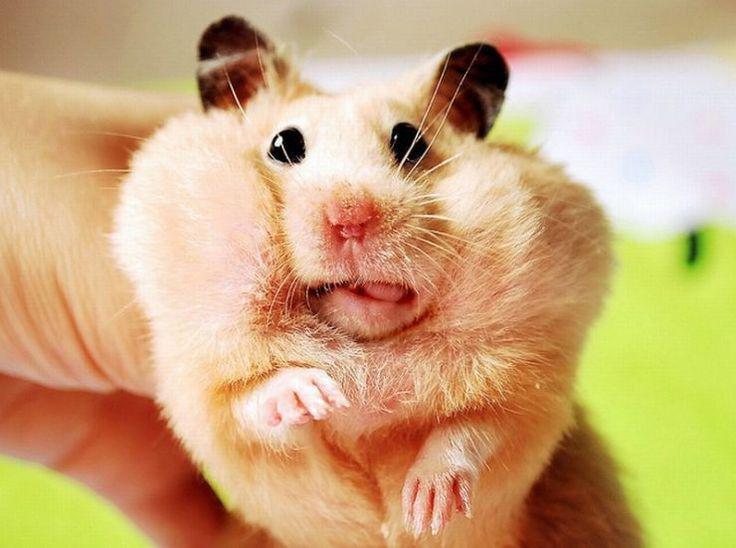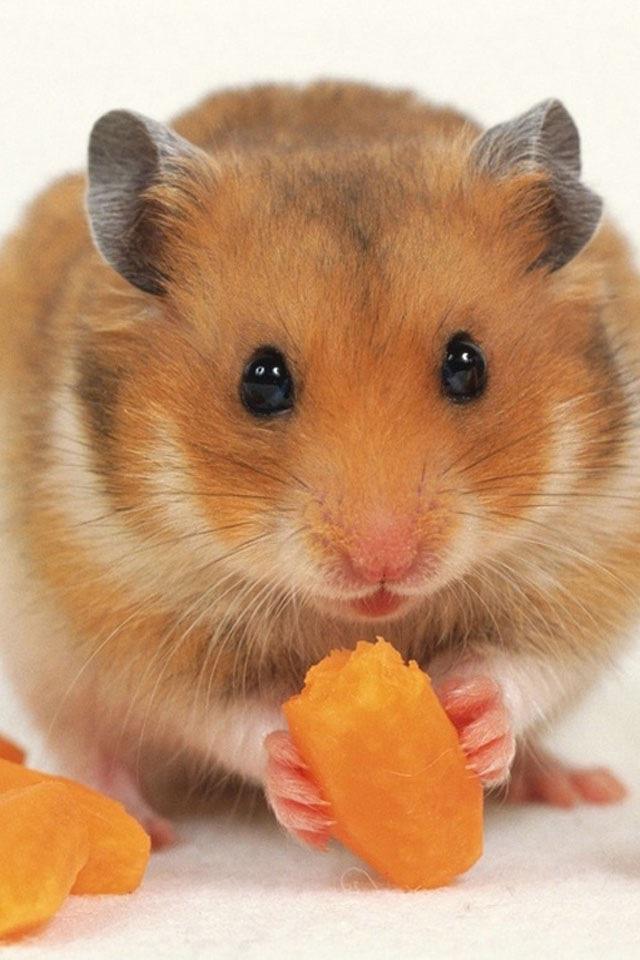The first image is the image on the left, the second image is the image on the right. Analyze the images presented: Is the assertion "Each image shows a hamster that is eating." valid? Answer yes or no. No. 